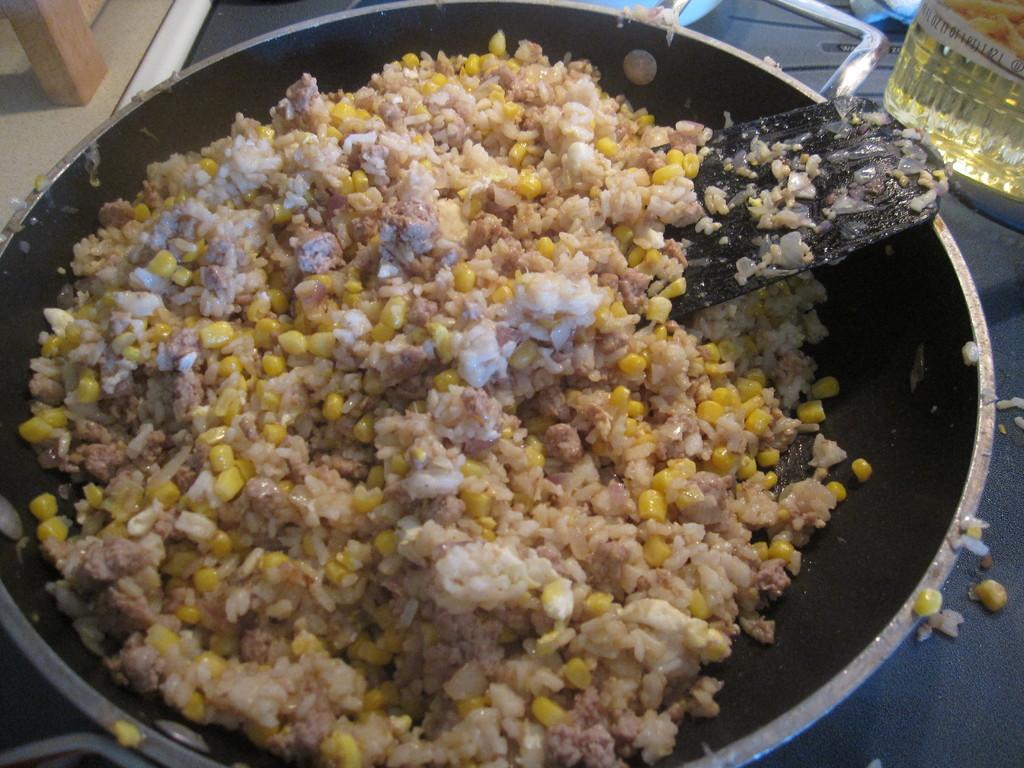What type of food can be seen in the image? There is corn and rice in the image. What cooking utensil is present in the image? There is a pan stick inside a pan in the image. What is used for cooking that is visible in the image? There is a bottle of oil beside the pan in the image. What type of book is placed on top of the corn in the image? There is no book present in the image; it only contains corn, rice, a pan stick, and a bottle of oil. 